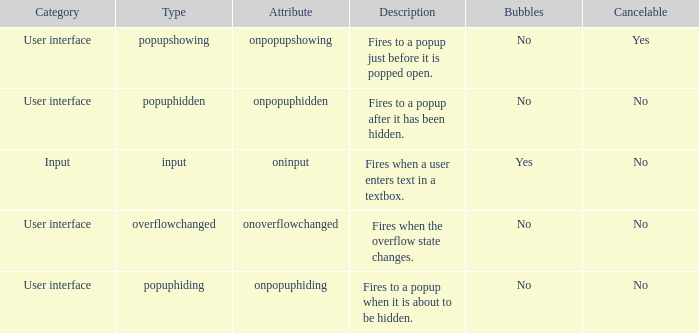Could you help me parse every detail presented in this table? {'header': ['Category', 'Type', 'Attribute', 'Description', 'Bubbles', 'Cancelable'], 'rows': [['User interface', 'popupshowing', 'onpopupshowing', 'Fires to a popup just before it is popped open.', 'No', 'Yes'], ['User interface', 'popuphidden', 'onpopuphidden', 'Fires to a popup after it has been hidden.', 'No', 'No'], ['Input', 'input', 'oninput', 'Fires when a user enters text in a textbox.', 'Yes', 'No'], ['User interface', 'overflowchanged', 'onoverflowchanged', 'Fires when the overflow state changes.', 'No', 'No'], ['User interface', 'popuphiding', 'onpopuphiding', 'Fires to a popup when it is about to be hidden.', 'No', 'No']]} What's the bubbles with attribute being onpopuphidden No. 